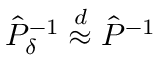Convert formula to latex. <formula><loc_0><loc_0><loc_500><loc_500>\hat { P } _ { \delta } ^ { - 1 } \overset { d } { \approx } \hat { P } ^ { - 1 }</formula> 